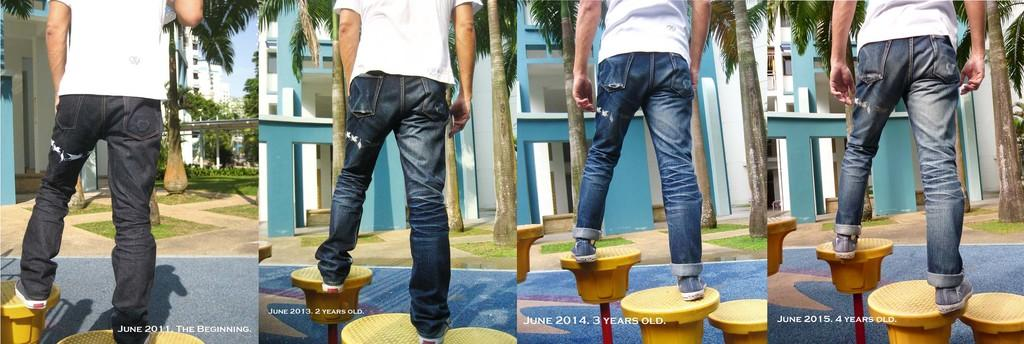What is present in one of the images? In one of the images, there is a man, stands, a road, trees, grassy land, buildings, and the sky is visible. Can you describe the setting of one of the images? One of the images shows a man in an outdoor area with stands, a road, trees, grassy land, buildings, and the sky visible. What type of surface can be seen in one of the images? In one of the images, there is a road and grassy land, which are both types of surfaces. What is the weather like in one of the images? The presence of trees and the sky visible in one of the images suggests that it is not raining or snowing, but the specific weather cannot be determined from the facts provided. What type of glue is being used to hold the buildings together in one of the images? There is no mention of glue or any adhesive being used to hold the buildings together in the image. How does the guide help the man navigate through one of the images? There is no guide or any navigational aid mentioned in the image, so it is not possible to determine how it might help the man navigate. 